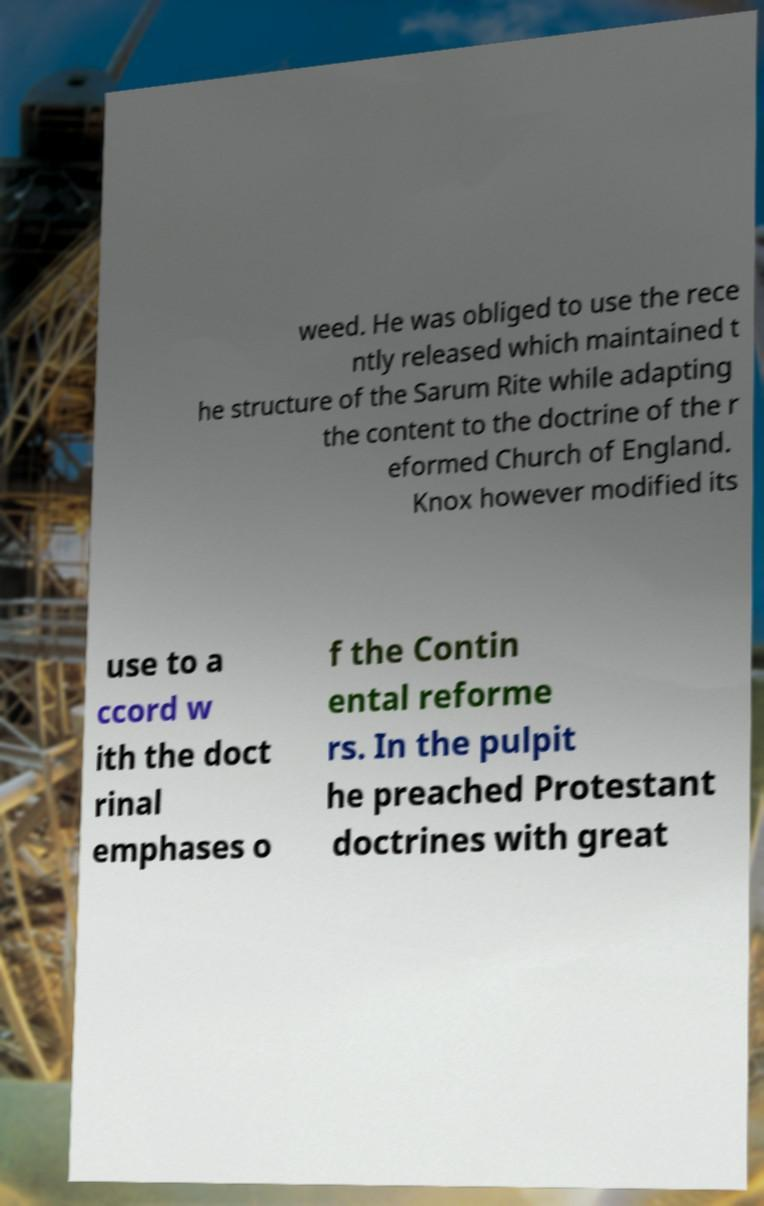For documentation purposes, I need the text within this image transcribed. Could you provide that? weed. He was obliged to use the rece ntly released which maintained t he structure of the Sarum Rite while adapting the content to the doctrine of the r eformed Church of England. Knox however modified its use to a ccord w ith the doct rinal emphases o f the Contin ental reforme rs. In the pulpit he preached Protestant doctrines with great 